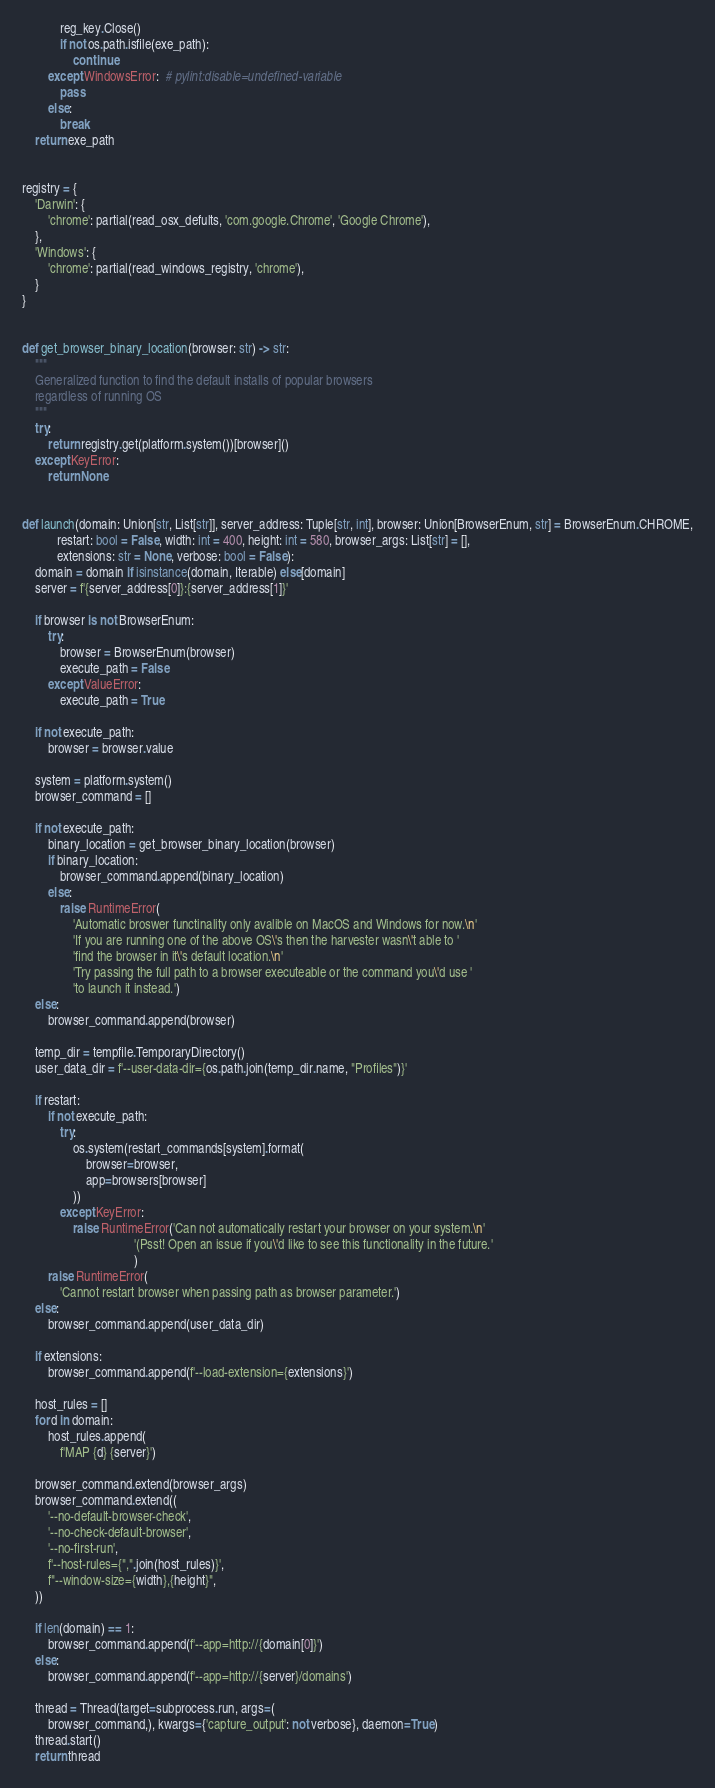Convert code to text. <code><loc_0><loc_0><loc_500><loc_500><_Python_>            reg_key.Close()
            if not os.path.isfile(exe_path):
                continue
        except WindowsError:  # pylint:disable=undefined-variable
            pass
        else:
            break
    return exe_path


registry = {
    'Darwin': {
        'chrome': partial(read_osx_defults, 'com.google.Chrome', 'Google Chrome'),
    },
    'Windows': {
        'chrome': partial(read_windows_registry, 'chrome'),
    }
}


def get_browser_binary_location(browser: str) -> str:
    """
    Generalized function to find the default installs of popular browsers
    regardless of running OS 
    """
    try:
        return registry.get(platform.system())[browser]()
    except KeyError:
        return None


def launch(domain: Union[str, List[str]], server_address: Tuple[str, int], browser: Union[BrowserEnum, str] = BrowserEnum.CHROME,
           restart: bool = False, width: int = 400, height: int = 580, browser_args: List[str] = [],
           extensions: str = None, verbose: bool = False):
    domain = domain if isinstance(domain, Iterable) else[domain]
    server = f'{server_address[0]}:{server_address[1]}'

    if browser is not BrowserEnum:
        try:
            browser = BrowserEnum(browser)
            execute_path = False
        except ValueError:
            execute_path = True

    if not execute_path:
        browser = browser.value

    system = platform.system()
    browser_command = []

    if not execute_path:
        binary_location = get_browser_binary_location(browser)
        if binary_location:
            browser_command.append(binary_location)
        else:
            raise RuntimeError(
                'Automatic broswer functinality only avalible on MacOS and Windows for now.\n'
                'If you are running one of the above OS\'s then the harvester wasn\'t able to '
                'find the browser in it\'s default location.\n'
                'Try passing the full path to a browser executeable or the command you\'d use '
                'to launch it instead.')
    else:
        browser_command.append(browser)

    temp_dir = tempfile.TemporaryDirectory()
    user_data_dir = f'--user-data-dir={os.path.join(temp_dir.name, "Profiles")}'

    if restart:
        if not execute_path:
            try:
                os.system(restart_commands[system].format(
                    browser=browser,
                    app=browsers[browser]
                ))
            except KeyError:
                raise RuntimeError('Can not automatically restart your browser on your system.\n'
                                   '(Psst! Open an issue if you\'d like to see this functionality in the future.'
                                   )
        raise RuntimeError(
            'Cannot restart browser when passing path as browser parameter.')
    else:
        browser_command.append(user_data_dir)

    if extensions:
        browser_command.append(f'--load-extension={extensions}')

    host_rules = []
    for d in domain:
        host_rules.append(
            f'MAP {d} {server}')

    browser_command.extend(browser_args)
    browser_command.extend((
        '--no-default-browser-check',
        '--no-check-default-browser',
        '--no-first-run',
        f'--host-rules={",".join(host_rules)}',
        f"--window-size={width},{height}",
    ))

    if len(domain) == 1:
        browser_command.append(f'--app=http://{domain[0]}')
    else:
        browser_command.append(f'--app=http://{server}/domains')

    thread = Thread(target=subprocess.run, args=(
        browser_command,), kwargs={'capture_output': not verbose}, daemon=True)
    thread.start()
    return thread
</code> 